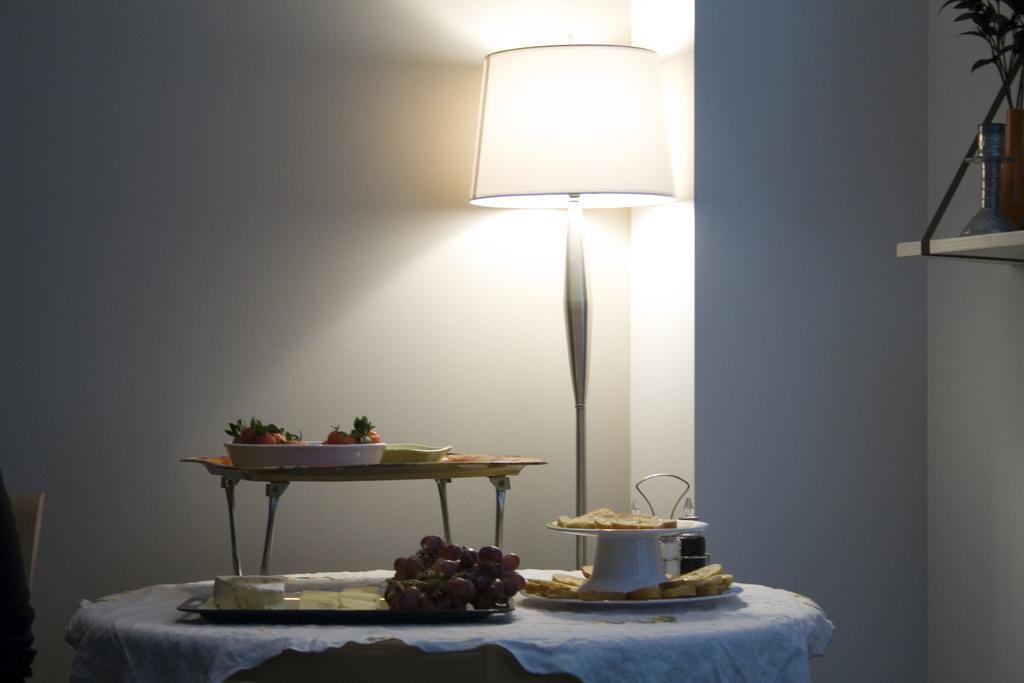Can you describe this image briefly? The picture is taken in a room. In the foreground of the picture there are table and a lamp. On the table there are platter, plates, jars and various food items. On the left there is a chair. On the right there are flower vase and desk. In the background it is wall painted white. 